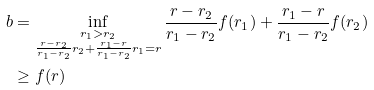Convert formula to latex. <formula><loc_0><loc_0><loc_500><loc_500>b & = \inf _ { \substack { r _ { 1 } > r _ { 2 } \\ \frac { r - r _ { 2 } } { r _ { 1 } - r _ { 2 } } r _ { 2 } + \frac { r _ { 1 } - r } { r _ { 1 } - r _ { 2 } } r _ { 1 } = r } } \frac { r - r _ { 2 } } { r _ { 1 } - r _ { 2 } } f ( r _ { 1 } ) + \frac { r _ { 1 } - r } { r _ { 1 } - r _ { 2 } } f ( r _ { 2 } ) \\ & \geq f ( r )</formula> 